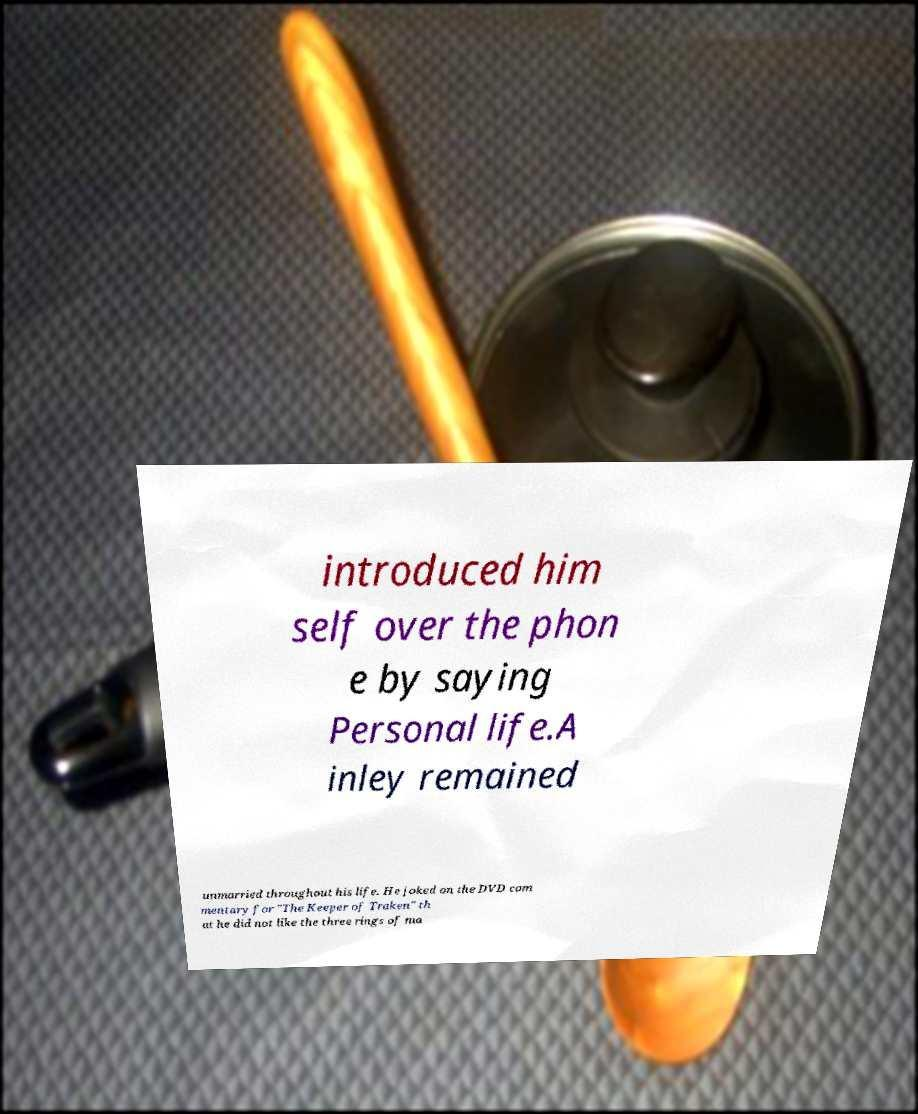Could you extract and type out the text from this image? introduced him self over the phon e by saying Personal life.A inley remained unmarried throughout his life. He joked on the DVD com mentary for "The Keeper of Traken" th at he did not like the three rings of ma 